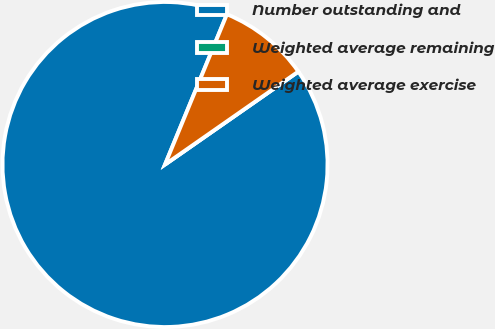Convert chart. <chart><loc_0><loc_0><loc_500><loc_500><pie_chart><fcel>Number outstanding and<fcel>Weighted average remaining<fcel>Weighted average exercise<nl><fcel>90.91%<fcel>0.0%<fcel>9.09%<nl></chart> 